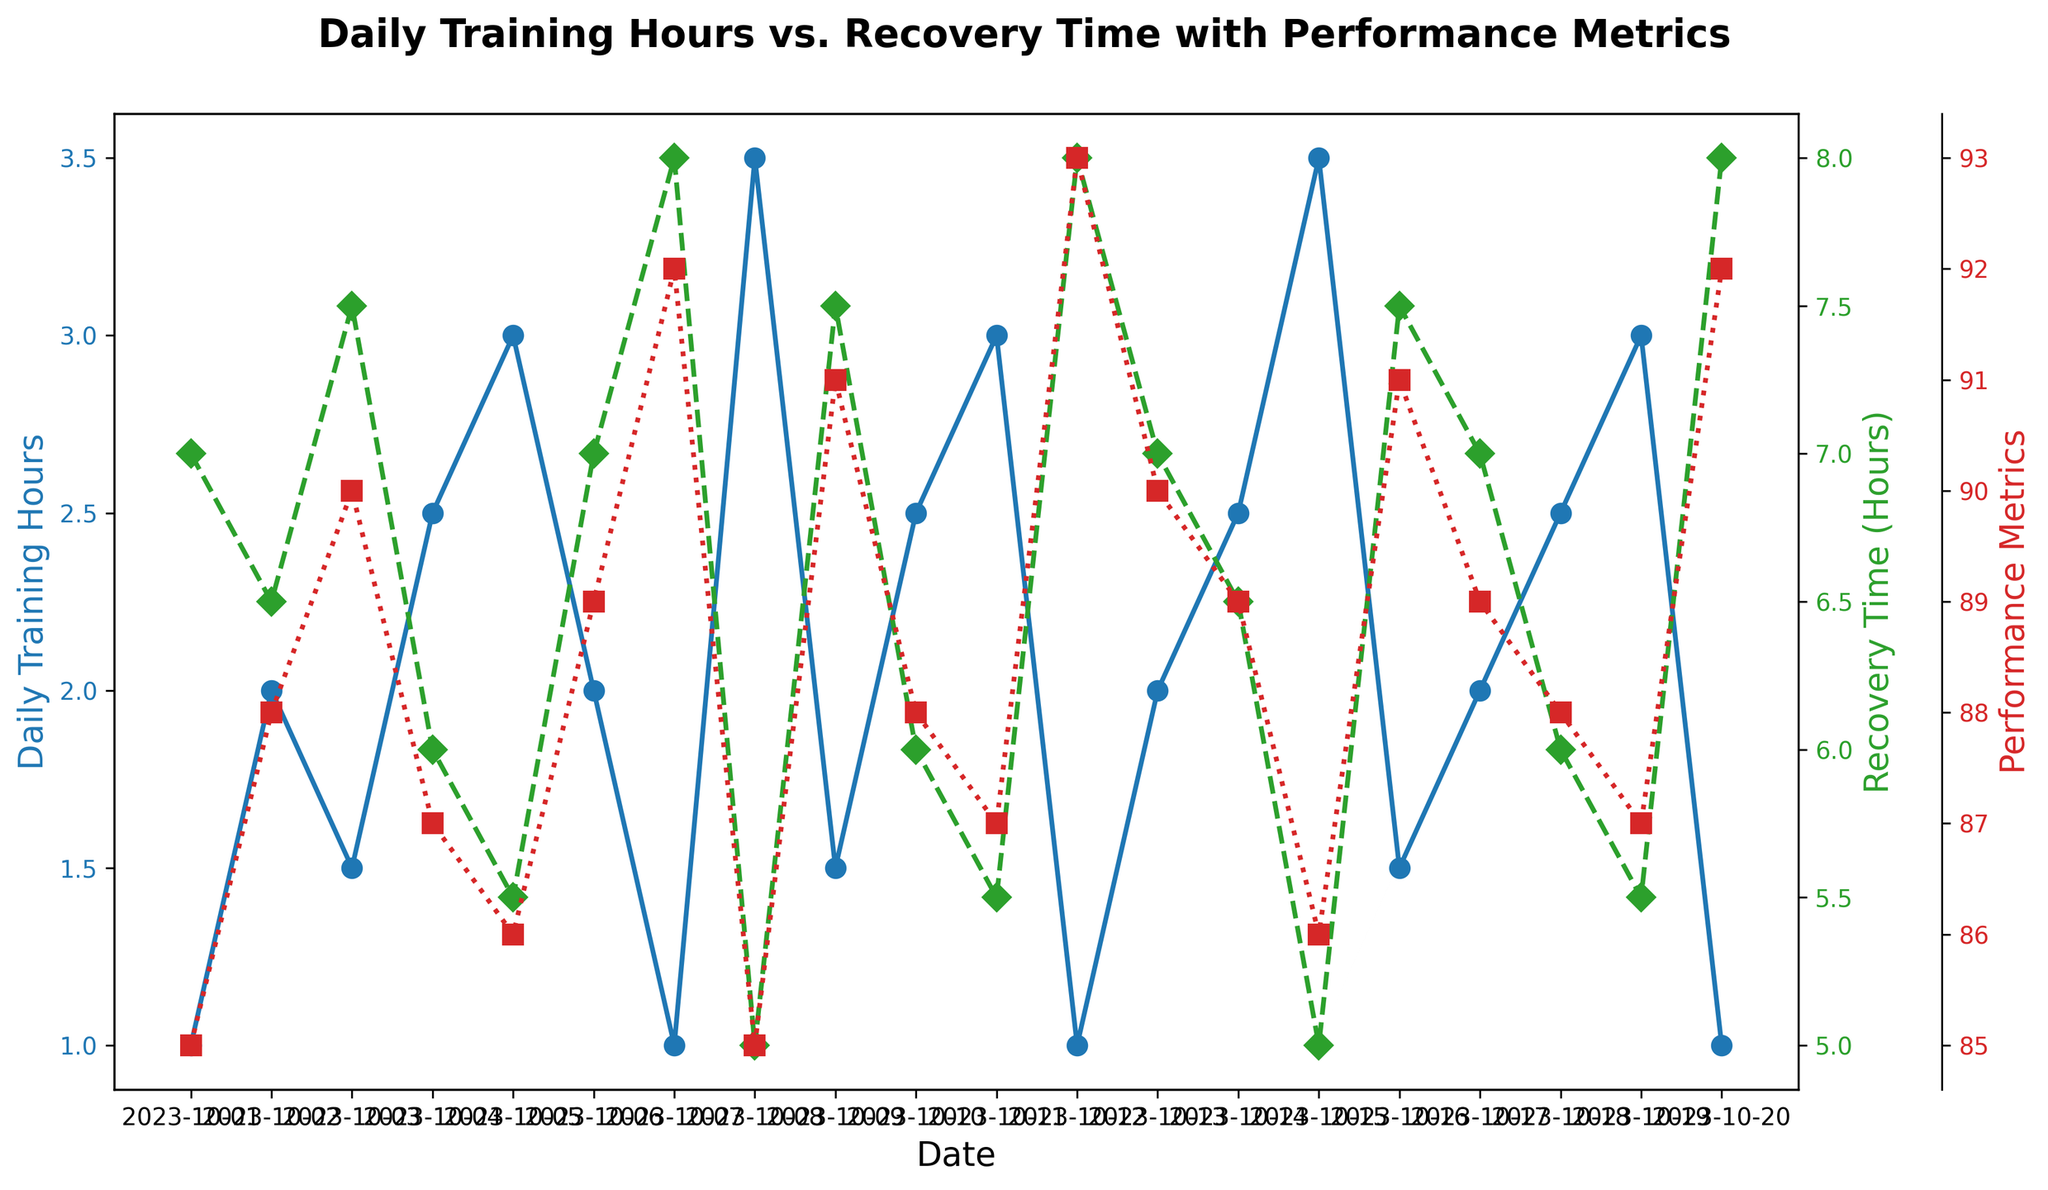What is the maximum number of Daily Training Hours recorded? The line with blue markers and a solid line represents the Daily Training Hours. To find the maximum, look for the highest point on this line. The highest value is 3.5 on October 8 and October 15.
Answer: 3.5 Which day has the lowest Recovery Time and what is the Performance Metrics for that day? The Recovery Time is shown with green markers and a dashed line. The lowest Recovery Time (5 hours) occurs on October 8 and October 15. On both days, the Performance Metrics are shown with red markers and a dotted line, which indicate values of 85 and 86 respectively.
Answer: October 8, 85; October 15, 86 What is the average Performance Metrics for days with at least 2 Daily Training Hours? For days with at least 2 Daily Training Hours (October 2, 4, 5, 8, 10, 11, 14, 15, 18, 19), the Performance Metrics are 88, 87, 86, 85, 88, 87, 89, 86, 88, 87. Sum these values (861) and divide by the number of days (10).
Answer: 86.1 When Daily Training Hours is 1 hour, how does the Recovery Time vary and what is the range? On days with 1 hour of Daily Training (October 1, 7, 12, 20), the Recovery Time values are 7, 8, 8, 8 hours respectively. The range is the difference between the maximum (8) and minimum (7).
Answer: Varies from 7 to 8 hours, range is 1 hour How does the Performance Metrics on October 7 compare to October 14? The Performance Metrics for October 7 (92) is shown by the red markers and is higher than for October 14 (89) by 3 units.
Answer: October 7 is higher by 3 units What is the total Recovery Time for October 1 to October 10? Sum the Recovery Time for October 1 to October 10: 7 + 6.5 + 7.5 + 6 + 5.5 + 7 + 8 + 5 + 7.5 + 6 = 65 hours.
Answer: 65 hours On which day is the difference between Daily Training Hours and Recovery Time the smallest? Calculate the absolute difference between Daily Training Hours and Recovery Time for each day. The smallest difference (0) is on October 3 and October 9 (both have 1.5 and 7.5 respectively).
Answer: October 3 and October 9 Which color represents Performance Metrics and how can it be identified in the plot? Performance Metrics is represented by red markers and a dotted line, as indicated in the plot's legend and the y-axis label color.
Answer: Red What is the trend of Daily Training Hours in the second week of October (October 8-14)? Observing the blue markers and line, the Daily Training Hours are 3.5 on October 8, 1.5 on October 9, 2.5 on October 10, 3 on October 11, 1 on October 12, 2 on October 13, and 2.5 on October 14, which shows variability with no clear increasing or decreasing trend.
Answer: Variable, no clear trend What is the relationship between Recovery Time and Performance Metrics? Generally, higher Recovery Times (green markers, dashed line) seem to correlate with higher Performance Metrics (red markers, dotted line), particularly evident on days with 8 hours of Recovery Time yielding high Performance Metrics (92, 93).
Answer: Higher Recovery Time tends to correlate with higher Performance Metrics 